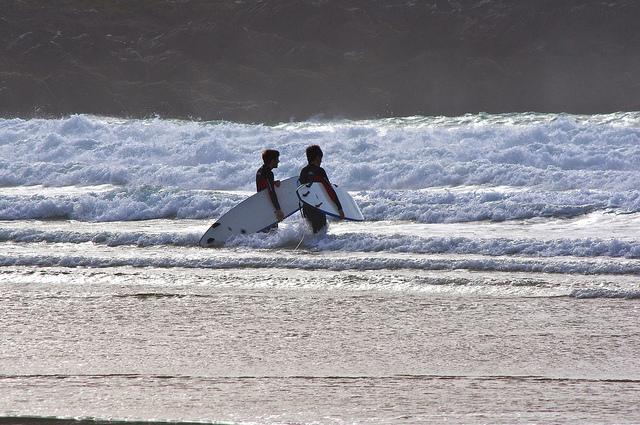What are the two men walking in?

Choices:
A) surf
B) desert
C) river
D) meadow surf 